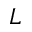Convert formula to latex. <formula><loc_0><loc_0><loc_500><loc_500>L</formula> 